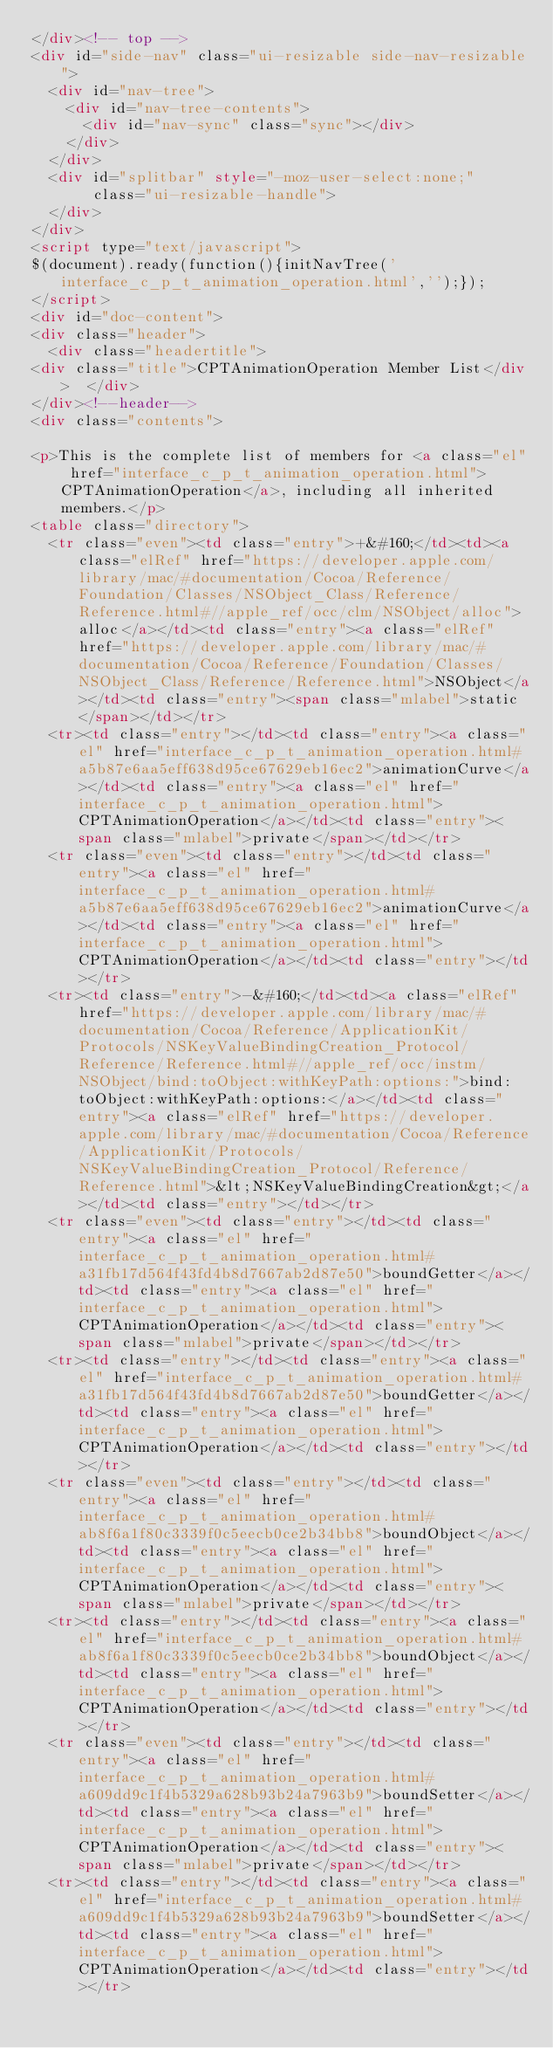Convert code to text. <code><loc_0><loc_0><loc_500><loc_500><_HTML_></div><!-- top -->
<div id="side-nav" class="ui-resizable side-nav-resizable">
  <div id="nav-tree">
    <div id="nav-tree-contents">
      <div id="nav-sync" class="sync"></div>
    </div>
  </div>
  <div id="splitbar" style="-moz-user-select:none;" 
       class="ui-resizable-handle">
  </div>
</div>
<script type="text/javascript">
$(document).ready(function(){initNavTree('interface_c_p_t_animation_operation.html','');});
</script>
<div id="doc-content">
<div class="header">
  <div class="headertitle">
<div class="title">CPTAnimationOperation Member List</div>  </div>
</div><!--header-->
<div class="contents">

<p>This is the complete list of members for <a class="el" href="interface_c_p_t_animation_operation.html">CPTAnimationOperation</a>, including all inherited members.</p>
<table class="directory">
  <tr class="even"><td class="entry">+&#160;</td><td><a class="elRef" href="https://developer.apple.com/library/mac/#documentation/Cocoa/Reference/Foundation/Classes/NSObject_Class/Reference/Reference.html#//apple_ref/occ/clm/NSObject/alloc">alloc</a></td><td class="entry"><a class="elRef" href="https://developer.apple.com/library/mac/#documentation/Cocoa/Reference/Foundation/Classes/NSObject_Class/Reference/Reference.html">NSObject</a></td><td class="entry"><span class="mlabel">static</span></td></tr>
  <tr><td class="entry"></td><td class="entry"><a class="el" href="interface_c_p_t_animation_operation.html#a5b87e6aa5eff638d95ce67629eb16ec2">animationCurve</a></td><td class="entry"><a class="el" href="interface_c_p_t_animation_operation.html">CPTAnimationOperation</a></td><td class="entry"><span class="mlabel">private</span></td></tr>
  <tr class="even"><td class="entry"></td><td class="entry"><a class="el" href="interface_c_p_t_animation_operation.html#a5b87e6aa5eff638d95ce67629eb16ec2">animationCurve</a></td><td class="entry"><a class="el" href="interface_c_p_t_animation_operation.html">CPTAnimationOperation</a></td><td class="entry"></td></tr>
  <tr><td class="entry">-&#160;</td><td><a class="elRef" href="https://developer.apple.com/library/mac/#documentation/Cocoa/Reference/ApplicationKit/Protocols/NSKeyValueBindingCreation_Protocol/Reference/Reference.html#//apple_ref/occ/instm/NSObject/bind:toObject:withKeyPath:options:">bind:toObject:withKeyPath:options:</a></td><td class="entry"><a class="elRef" href="https://developer.apple.com/library/mac/#documentation/Cocoa/Reference/ApplicationKit/Protocols/NSKeyValueBindingCreation_Protocol/Reference/Reference.html">&lt;NSKeyValueBindingCreation&gt;</a></td><td class="entry"></td></tr>
  <tr class="even"><td class="entry"></td><td class="entry"><a class="el" href="interface_c_p_t_animation_operation.html#a31fb17d564f43fd4b8d7667ab2d87e50">boundGetter</a></td><td class="entry"><a class="el" href="interface_c_p_t_animation_operation.html">CPTAnimationOperation</a></td><td class="entry"><span class="mlabel">private</span></td></tr>
  <tr><td class="entry"></td><td class="entry"><a class="el" href="interface_c_p_t_animation_operation.html#a31fb17d564f43fd4b8d7667ab2d87e50">boundGetter</a></td><td class="entry"><a class="el" href="interface_c_p_t_animation_operation.html">CPTAnimationOperation</a></td><td class="entry"></td></tr>
  <tr class="even"><td class="entry"></td><td class="entry"><a class="el" href="interface_c_p_t_animation_operation.html#ab8f6a1f80c3339f0c5eecb0ce2b34bb8">boundObject</a></td><td class="entry"><a class="el" href="interface_c_p_t_animation_operation.html">CPTAnimationOperation</a></td><td class="entry"><span class="mlabel">private</span></td></tr>
  <tr><td class="entry"></td><td class="entry"><a class="el" href="interface_c_p_t_animation_operation.html#ab8f6a1f80c3339f0c5eecb0ce2b34bb8">boundObject</a></td><td class="entry"><a class="el" href="interface_c_p_t_animation_operation.html">CPTAnimationOperation</a></td><td class="entry"></td></tr>
  <tr class="even"><td class="entry"></td><td class="entry"><a class="el" href="interface_c_p_t_animation_operation.html#a609dd9c1f4b5329a628b93b24a7963b9">boundSetter</a></td><td class="entry"><a class="el" href="interface_c_p_t_animation_operation.html">CPTAnimationOperation</a></td><td class="entry"><span class="mlabel">private</span></td></tr>
  <tr><td class="entry"></td><td class="entry"><a class="el" href="interface_c_p_t_animation_operation.html#a609dd9c1f4b5329a628b93b24a7963b9">boundSetter</a></td><td class="entry"><a class="el" href="interface_c_p_t_animation_operation.html">CPTAnimationOperation</a></td><td class="entry"></td></tr></code> 